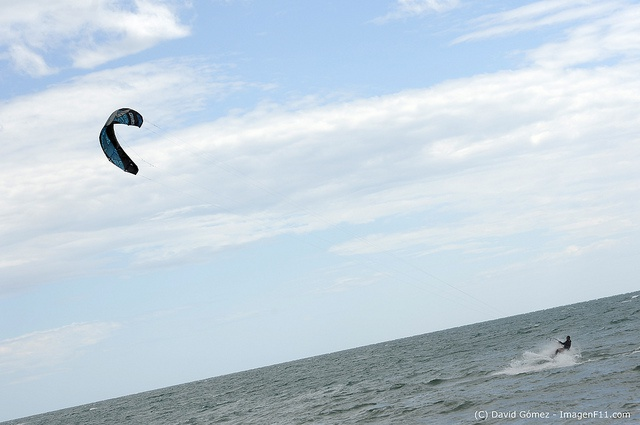Describe the objects in this image and their specific colors. I can see kite in lightgray, black, blue, gray, and darkblue tones and people in lightgray, black, gray, and darkgray tones in this image. 